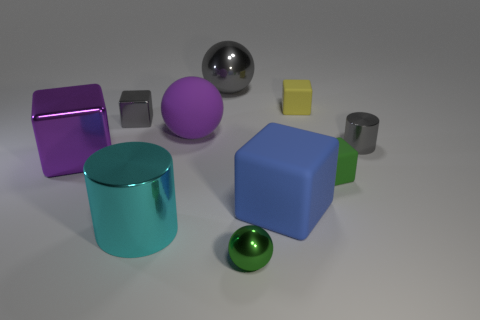Subtract 1 cubes. How many cubes are left? 4 Subtract all gray cylinders. Subtract all purple cubes. How many cylinders are left? 1 Subtract all cylinders. How many objects are left? 8 Subtract 1 green balls. How many objects are left? 9 Subtract all small gray metal objects. Subtract all tiny objects. How many objects are left? 3 Add 2 tiny yellow matte blocks. How many tiny yellow matte blocks are left? 3 Add 5 large gray metal balls. How many large gray metal balls exist? 6 